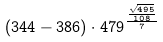Convert formula to latex. <formula><loc_0><loc_0><loc_500><loc_500>( 3 4 4 - 3 8 6 ) \cdot 4 7 9 ^ { \frac { \frac { \sqrt { 4 9 5 } } { 1 0 8 } } { 7 } }</formula> 